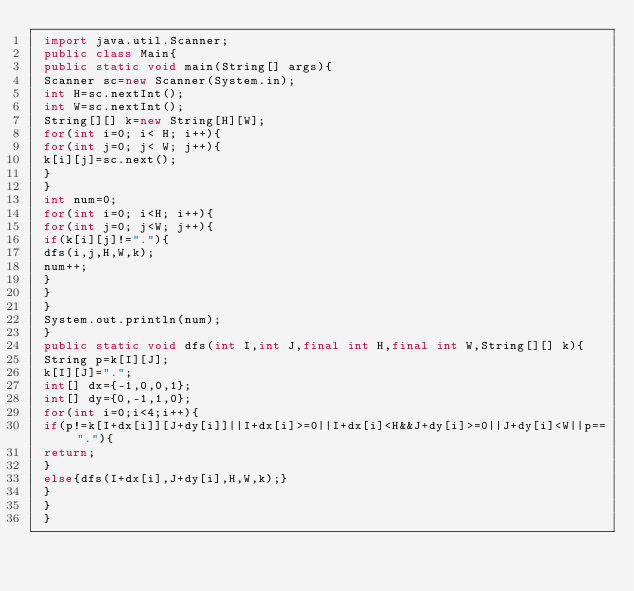Convert code to text. <code><loc_0><loc_0><loc_500><loc_500><_Java_> import java.util.Scanner; 
 public class Main{
 public static void main(String[] args){
 Scanner sc=new Scanner(System.in);
 int H=sc.nextInt();
 int W=sc.nextInt();
 String[][] k=new String[H][W];
 for(int i=0; i< H; i++){
 for(int j=0; j< W; j++){
 k[i][j]=sc.next();
 }
 }
 int num=0;
 for(int i=0; i<H; i++){
 for(int j=0; j<W; j++){
 if(k[i][j]!="."){
 dfs(i,j,H,W,k);
 num++;
 }
 }
 }
 System.out.println(num);
 }
 public static void dfs(int I,int J,final int H,final int W,String[][] k){
 String p=k[I][J];
 k[I][J]=".";
 int[] dx={-1,0,0,1};
 int[] dy={0,-1,1,0};
 for(int i=0;i<4;i++){
 if(p!=k[I+dx[i]][J+dy[i]]||I+dx[i]>=0||I+dx[i]<H&&J+dy[i]>=0||J+dy[i]<W||p=="."){
 return;
 }
 else{dfs(I+dx[i],J+dy[i],H,W,k);}
 }
 }
 }</code> 